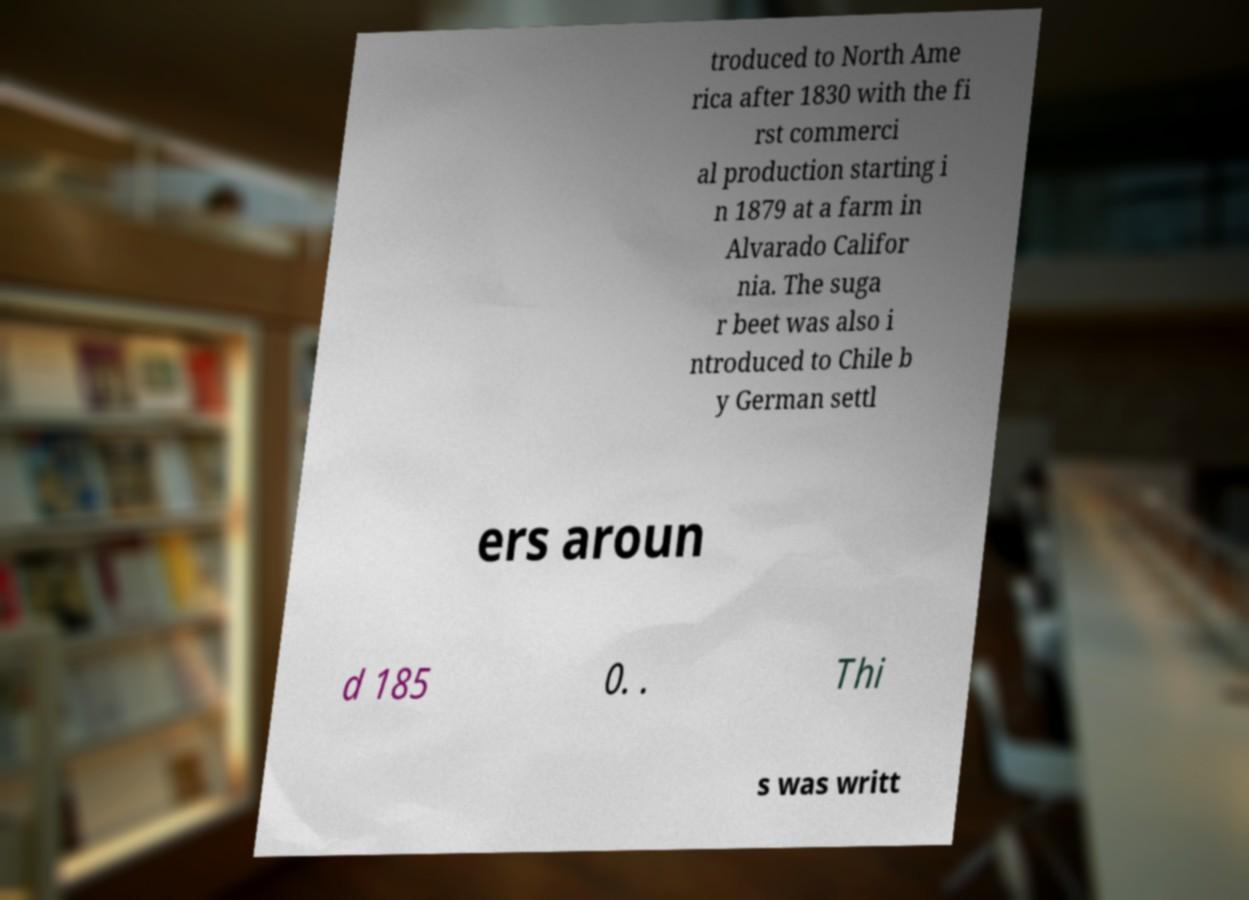Can you accurately transcribe the text from the provided image for me? troduced to North Ame rica after 1830 with the fi rst commerci al production starting i n 1879 at a farm in Alvarado Califor nia. The suga r beet was also i ntroduced to Chile b y German settl ers aroun d 185 0. . Thi s was writt 